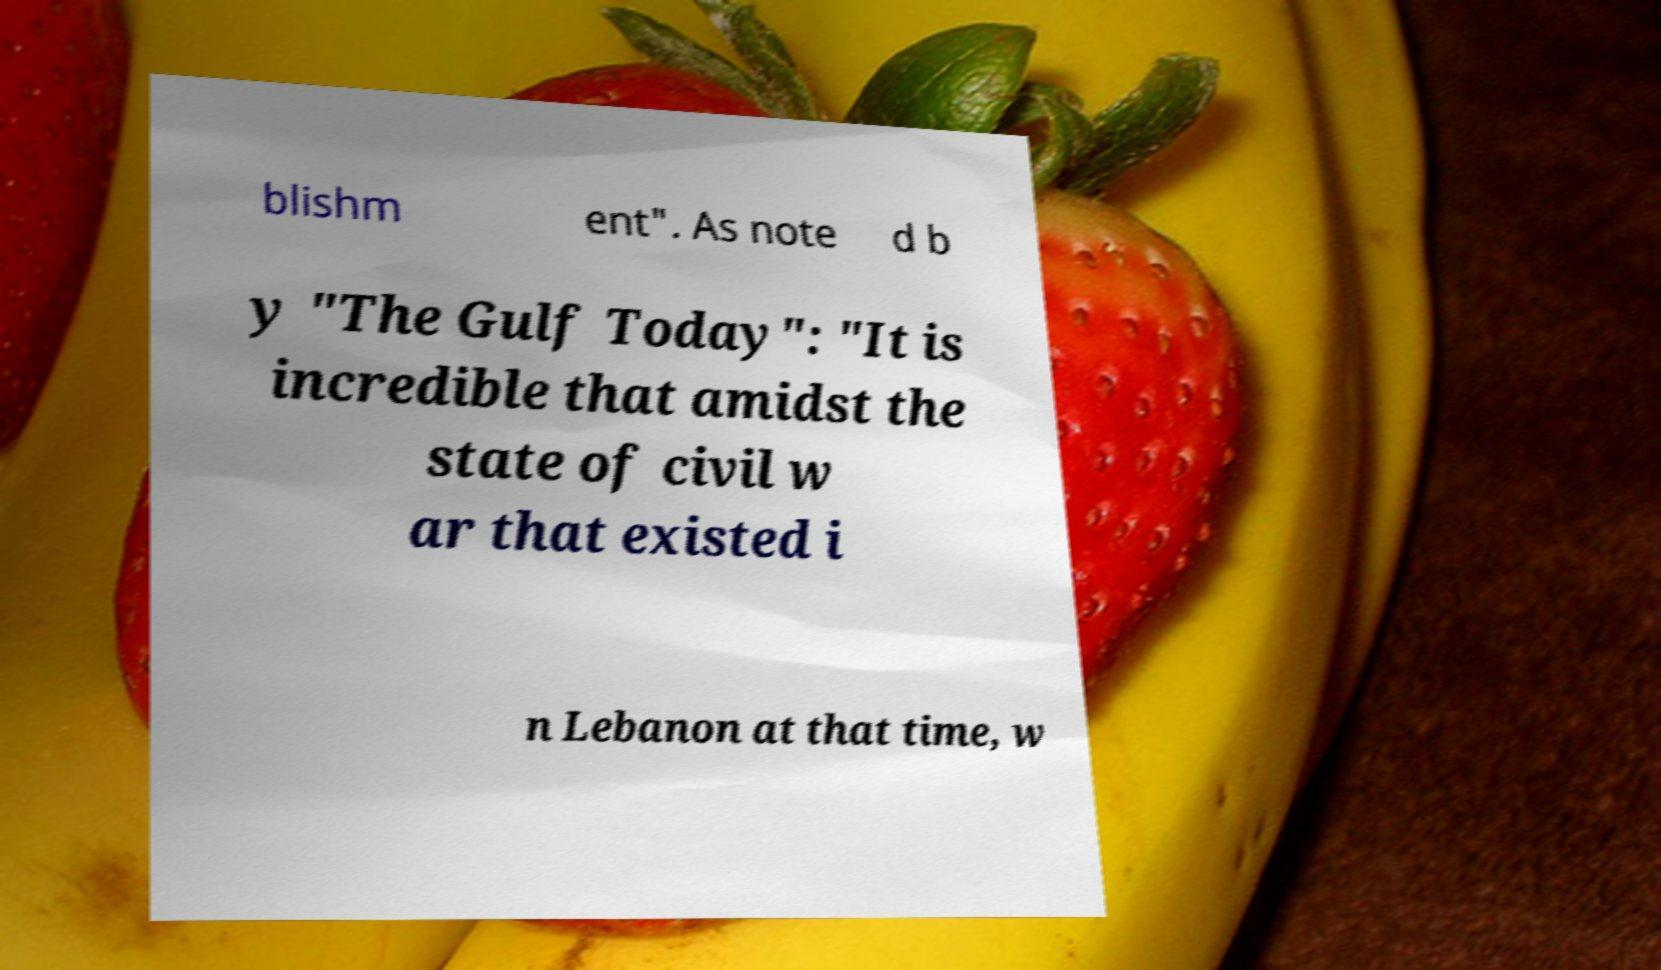I need the written content from this picture converted into text. Can you do that? blishm ent". As note d b y "The Gulf Today": "It is incredible that amidst the state of civil w ar that existed i n Lebanon at that time, w 